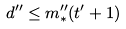<formula> <loc_0><loc_0><loc_500><loc_500>d ^ { \prime \prime } \leq m ^ { \prime \prime } _ { * } ( t ^ { \prime } + 1 )</formula> 